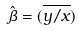Convert formula to latex. <formula><loc_0><loc_0><loc_500><loc_500>\hat { \beta } = ( \overline { y / x } )</formula> 